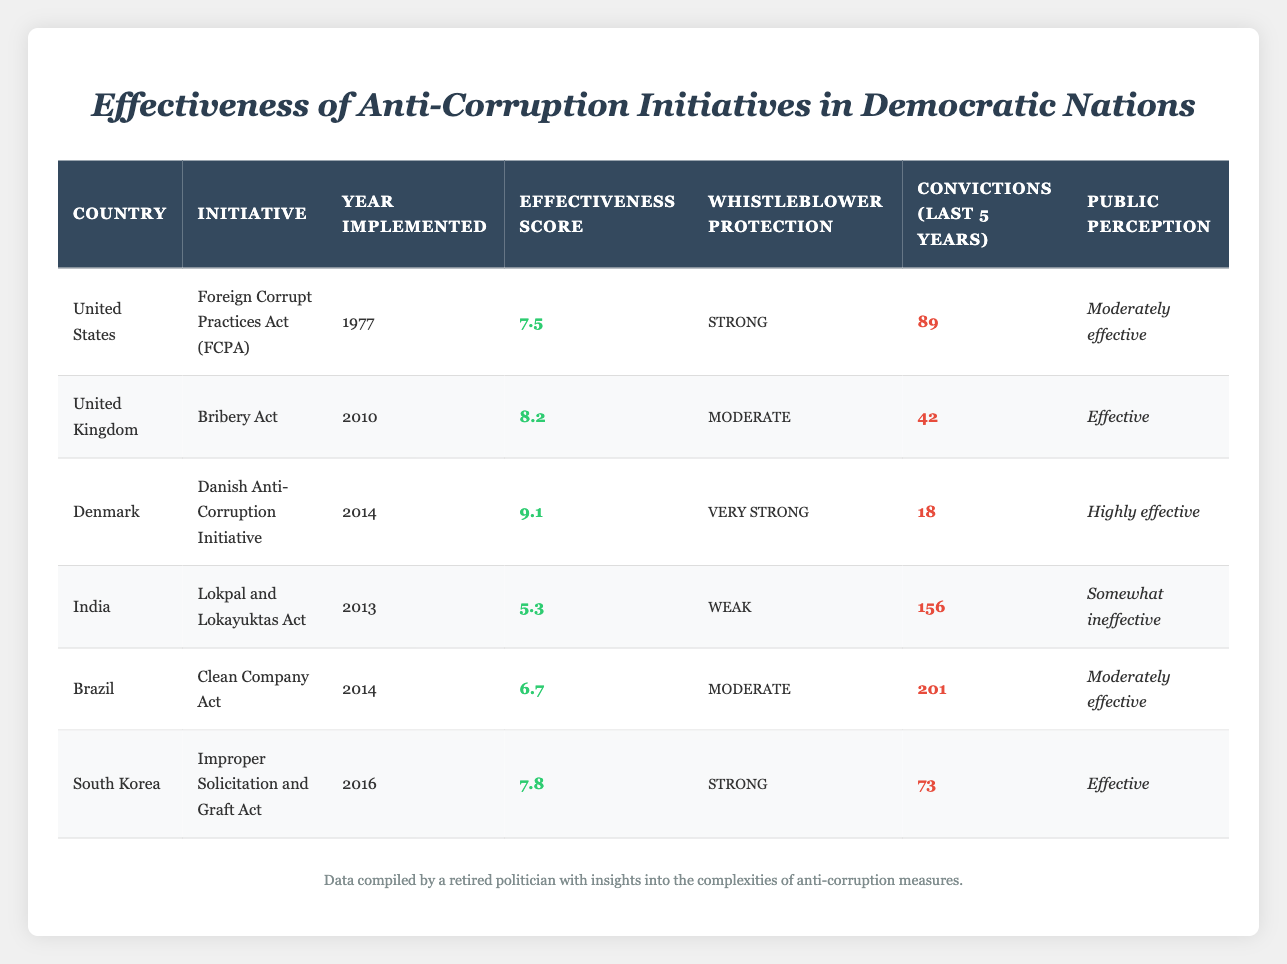What is the effectiveness score of Denmark's initiative? The table lists Denmark's initiative, the Danish Anti-Corruption Initiative, which has an effectiveness score of 9.1.
Answer: 9.1 Which country has the strongest whistleblower protection? According to the table, Denmark has the strongest whistleblower protection, classified as "Very Strong".
Answer: Denmark What is the total number of convictions in the last five years for India and Brazil combined? India's total convictions in the last five years are 156, and Brazil's are 201. Adding them gives 156 + 201 = 357.
Answer: 357 Is the public perception of the anti-corruption initiative in the United Kingdom effective? The public perception for the UK's Bribery Act is listed as "Effective", indicating that it is favorable.
Answer: Yes Which initiative was implemented most recently, and what is its effectiveness score? South Korea's Improper Solicitation and Graft Act was implemented in 2016, which is the most recent. Its effectiveness score is 7.8.
Answer: 7.8 How many countries have a public perception rated as "Moderately effective"? The countries with a "Moderately effective" public perception are the United States and Brazil, so there are 2 countries.
Answer: 2 What is the difference in effectiveness scores between India's initiative and Denmark's initiative? India's Lokpal and Lokayuktas Act has a score of 5.3, while Denmark's initiative has a score of 9.1. The difference is 9.1 - 5.3 = 3.8.
Answer: 3.8 What percentage of the total convictions in the last five years belongs to India? The total number of convictions across all countries is 89 + 42 + 18 + 156 + 201 + 73 = 579. India's convictions are 156, so the percentage is (156 / 579) * 100 ≈ 26.96%.
Answer: Approximately 27% Which initiative has a lower effectiveness score than the South Korea initiative? South Korea's initiative has an effectiveness score of 7.8. Referring to the table, both India's (5.3) and Brazil's (6.7) initiatives have lower scores.
Answer: India and Brazil 